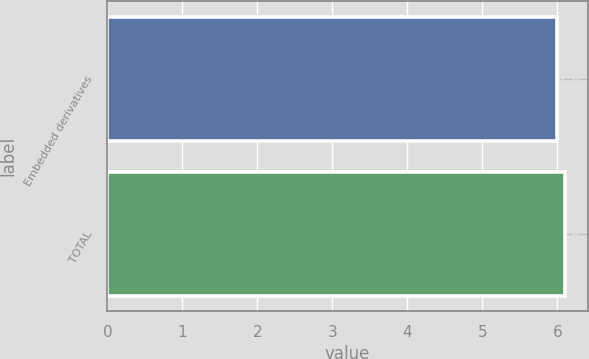Convert chart to OTSL. <chart><loc_0><loc_0><loc_500><loc_500><bar_chart><fcel>Embedded derivatives<fcel>TOTAL<nl><fcel>6<fcel>6.1<nl></chart> 